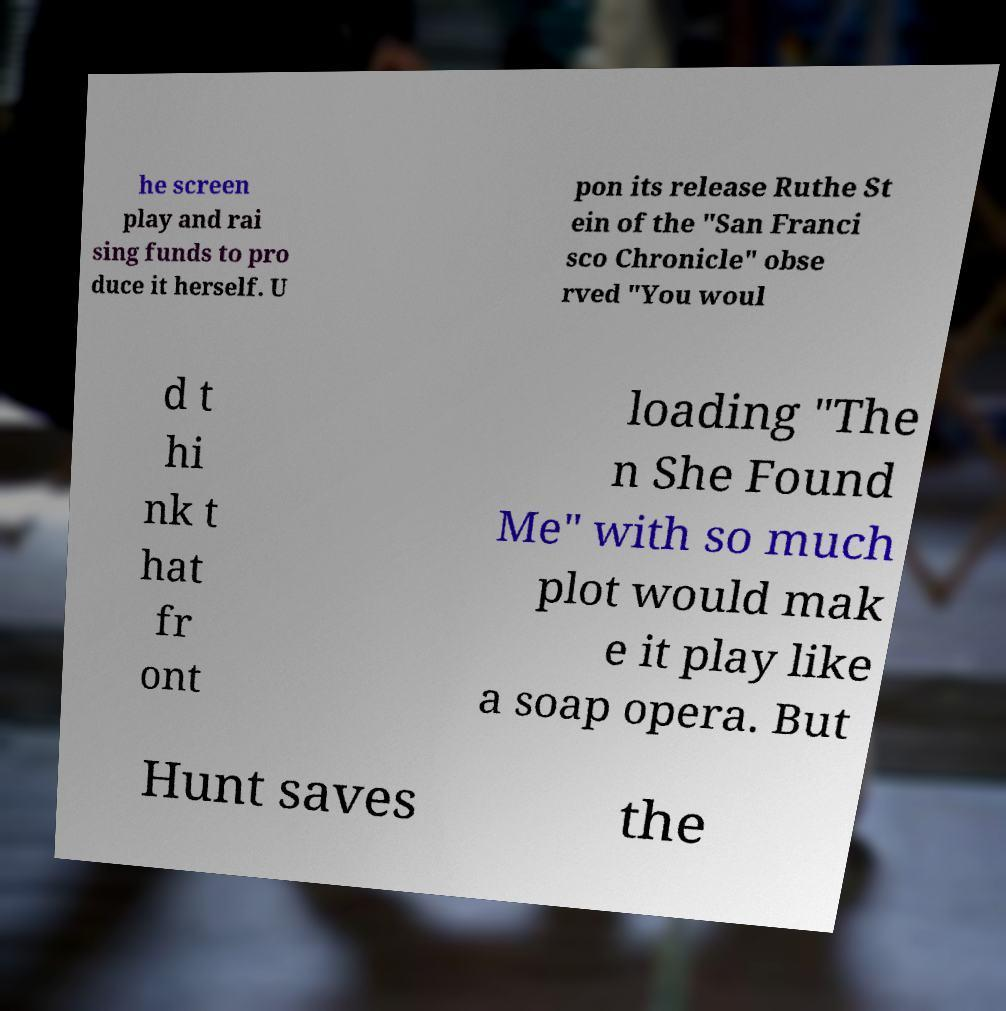What messages or text are displayed in this image? I need them in a readable, typed format. he screen play and rai sing funds to pro duce it herself. U pon its release Ruthe St ein of the "San Franci sco Chronicle" obse rved "You woul d t hi nk t hat fr ont loading "The n She Found Me" with so much plot would mak e it play like a soap opera. But Hunt saves the 